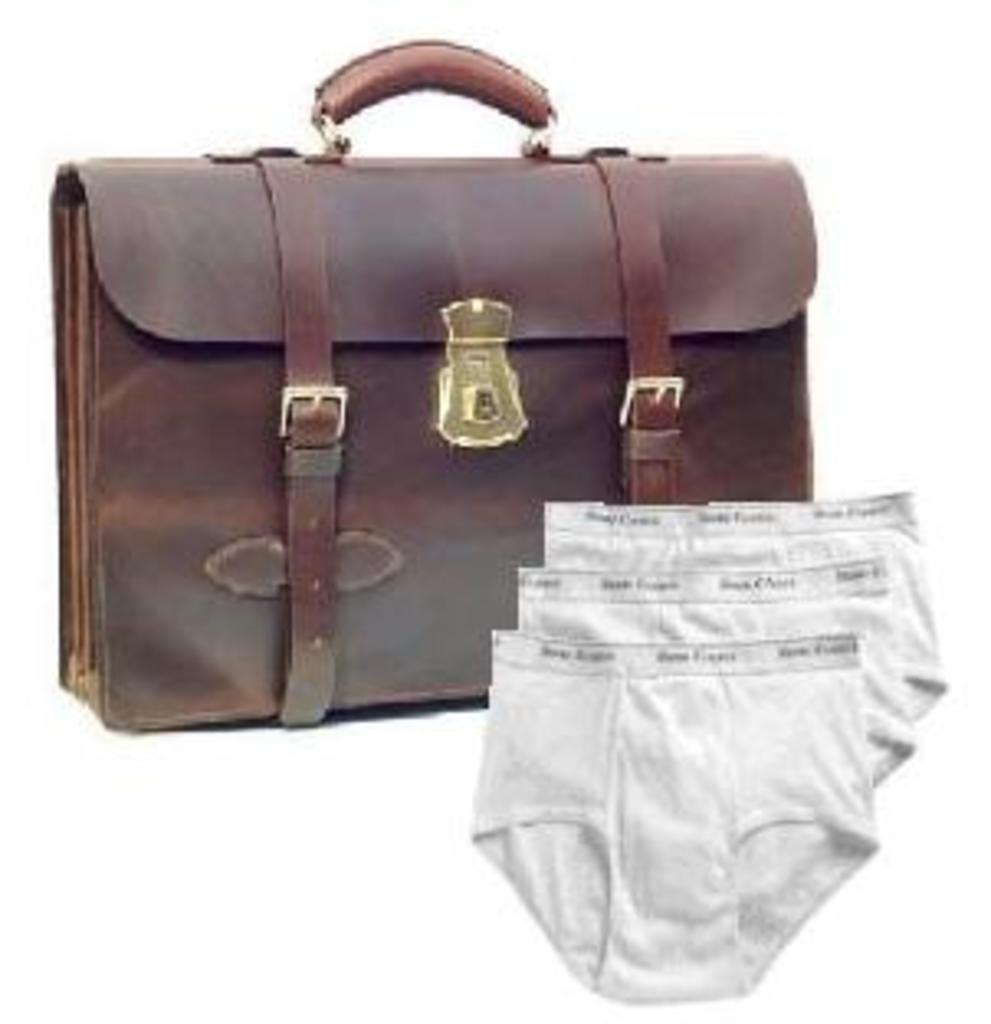What type of bag is in the image? There is a leather bag in the image. Where is the leather bag located in the image? The leather bag is on the right side of the image. What other items can be seen on the right side of the image? There are undergarments on the right side of the image. What type of base is supporting the undergarments in the image? There is no base visible in the image that is supporting the undergarments; they are simply placed on the right side. 